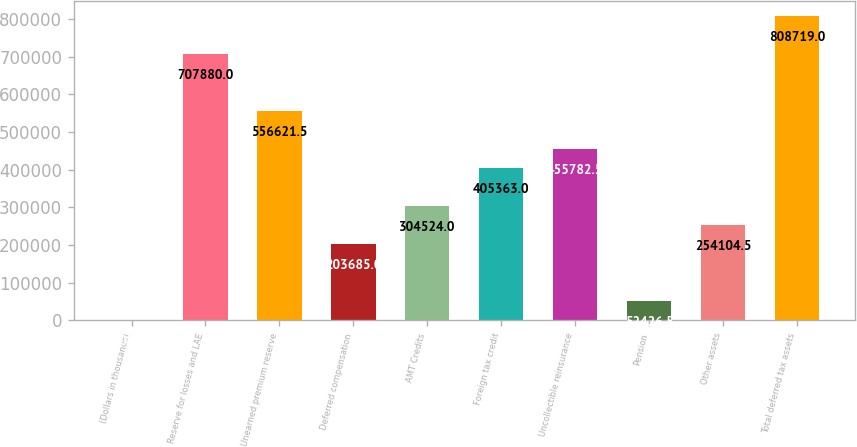Convert chart. <chart><loc_0><loc_0><loc_500><loc_500><bar_chart><fcel>(Dollars in thousands)<fcel>Reserve for losses and LAE<fcel>Unearned premium reserve<fcel>Deferred compensation<fcel>AMT Credits<fcel>Foreign tax credit<fcel>Uncollectible reinsurance<fcel>Pension<fcel>Other assets<fcel>Total deferred tax assets<nl><fcel>2007<fcel>707880<fcel>556622<fcel>203685<fcel>304524<fcel>405363<fcel>455782<fcel>52426.5<fcel>254104<fcel>808719<nl></chart> 